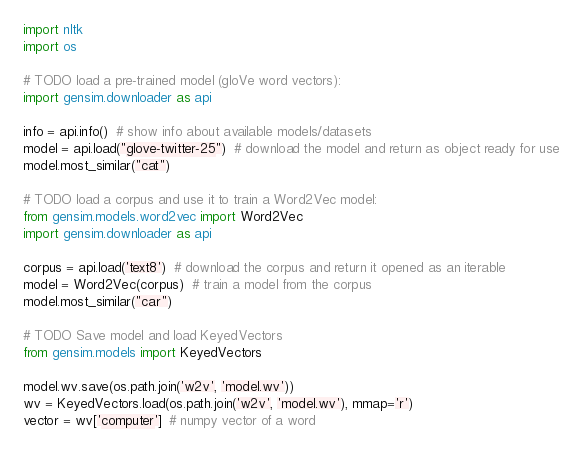Convert code to text. <code><loc_0><loc_0><loc_500><loc_500><_Python_>import nltk
import os

# TODO load a pre-trained model (gloVe word vectors):
import gensim.downloader as api

info = api.info()  # show info about available models/datasets
model = api.load("glove-twitter-25")  # download the model and return as object ready for use
model.most_similar("cat")

# TODO load a corpus and use it to train a Word2Vec model:
from gensim.models.word2vec import Word2Vec
import gensim.downloader as api

corpus = api.load('text8')  # download the corpus and return it opened as an iterable
model = Word2Vec(corpus)  # train a model from the corpus
model.most_similar("car")

# TODO Save model and load KeyedVectors
from gensim.models import KeyedVectors

model.wv.save(os.path.join('w2v', 'model.wv'))
wv = KeyedVectors.load(os.path.join('w2v', 'model.wv'), mmap='r')
vector = wv['computer']  # numpy vector of a word</code> 